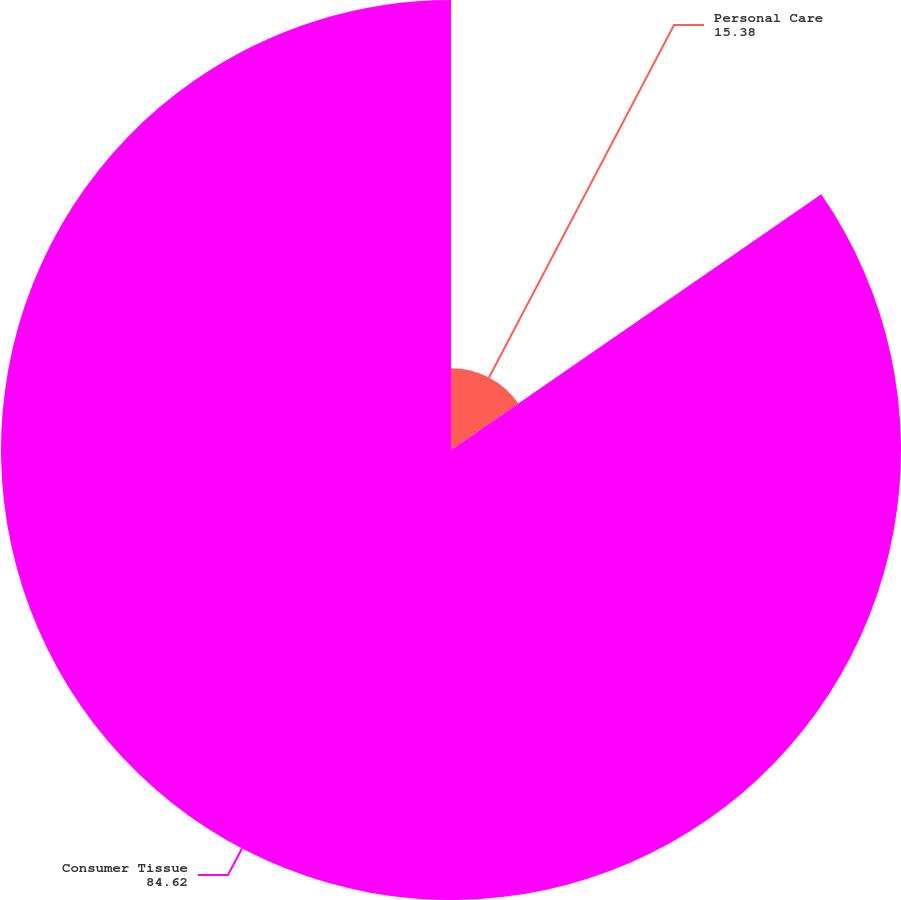Convert chart to OTSL. <chart><loc_0><loc_0><loc_500><loc_500><pie_chart><fcel>Personal Care<fcel>Consumer Tissue<nl><fcel>15.38%<fcel>84.62%<nl></chart> 